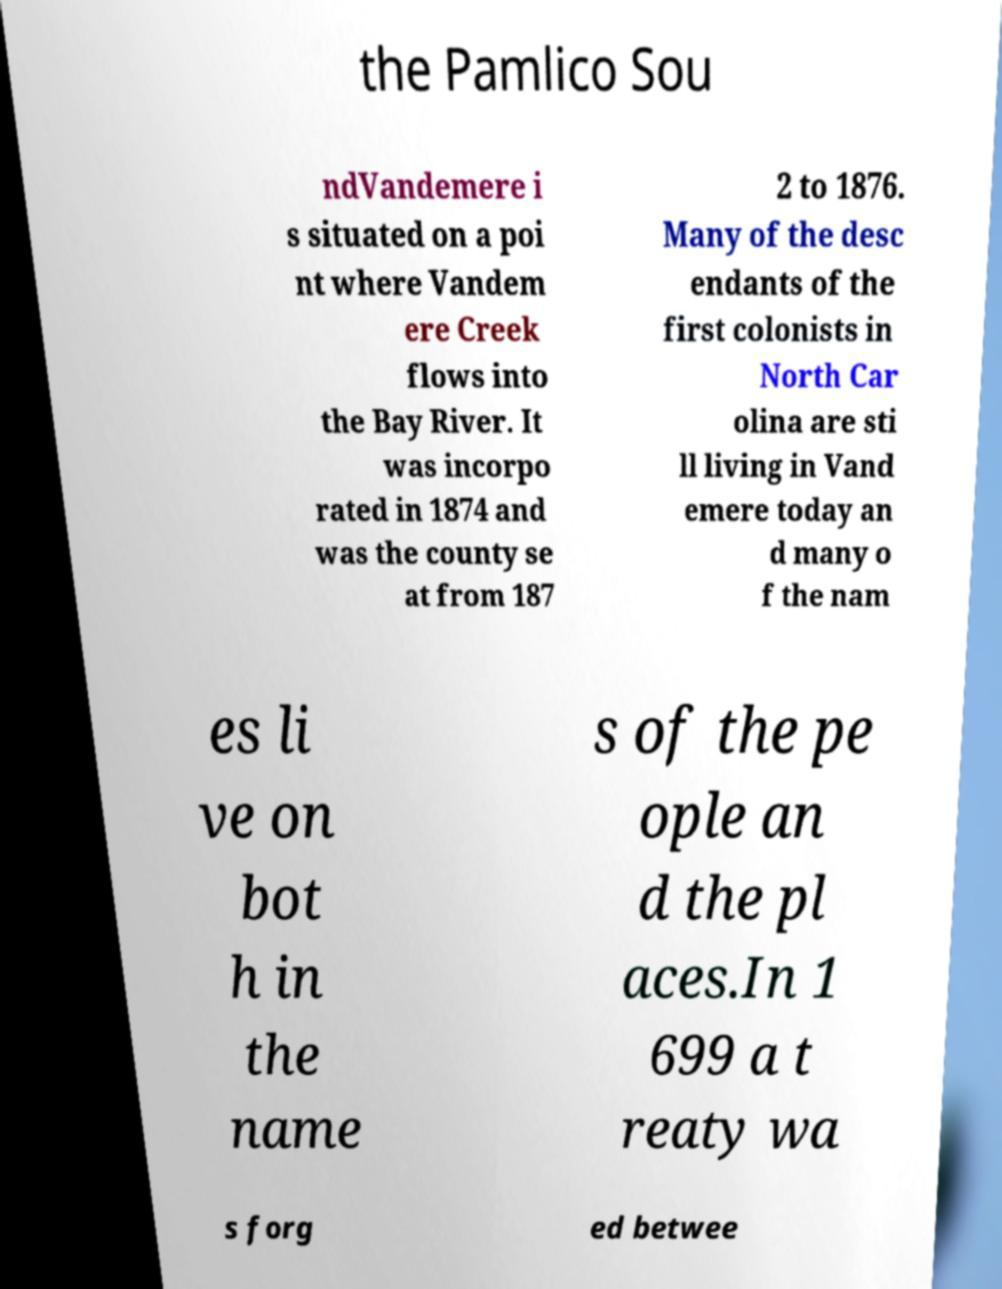Could you extract and type out the text from this image? the Pamlico Sou ndVandemere i s situated on a poi nt where Vandem ere Creek flows into the Bay River. It was incorpo rated in 1874 and was the county se at from 187 2 to 1876. Many of the desc endants of the first colonists in North Car olina are sti ll living in Vand emere today an d many o f the nam es li ve on bot h in the name s of the pe ople an d the pl aces.In 1 699 a t reaty wa s forg ed betwee 